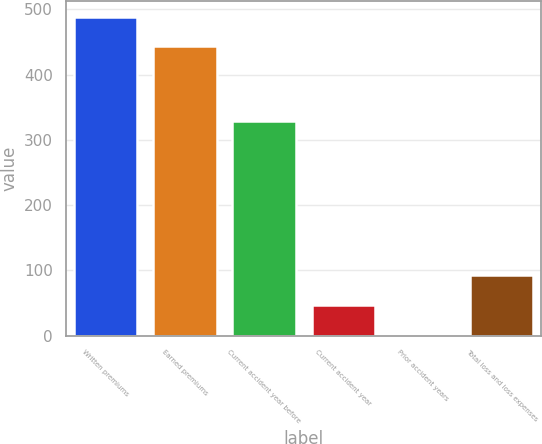Convert chart to OTSL. <chart><loc_0><loc_0><loc_500><loc_500><bar_chart><fcel>Written premiums<fcel>Earned premiums<fcel>Current accident year before<fcel>Current accident year<fcel>Prior accident years<fcel>Total loss and loss expenses<nl><fcel>488.9<fcel>443<fcel>329<fcel>46.9<fcel>1<fcel>92.8<nl></chart> 